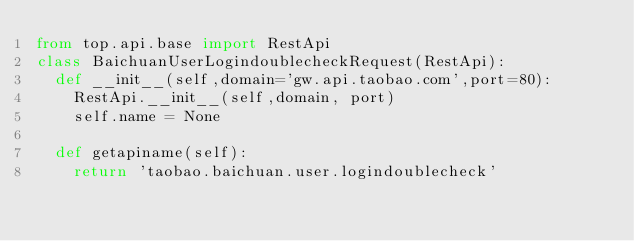<code> <loc_0><loc_0><loc_500><loc_500><_Python_>from top.api.base import RestApi
class BaichuanUserLogindoublecheckRequest(RestApi):
	def __init__(self,domain='gw.api.taobao.com',port=80):
		RestApi.__init__(self,domain, port)
		self.name = None

	def getapiname(self):
		return 'taobao.baichuan.user.logindoublecheck'
</code> 